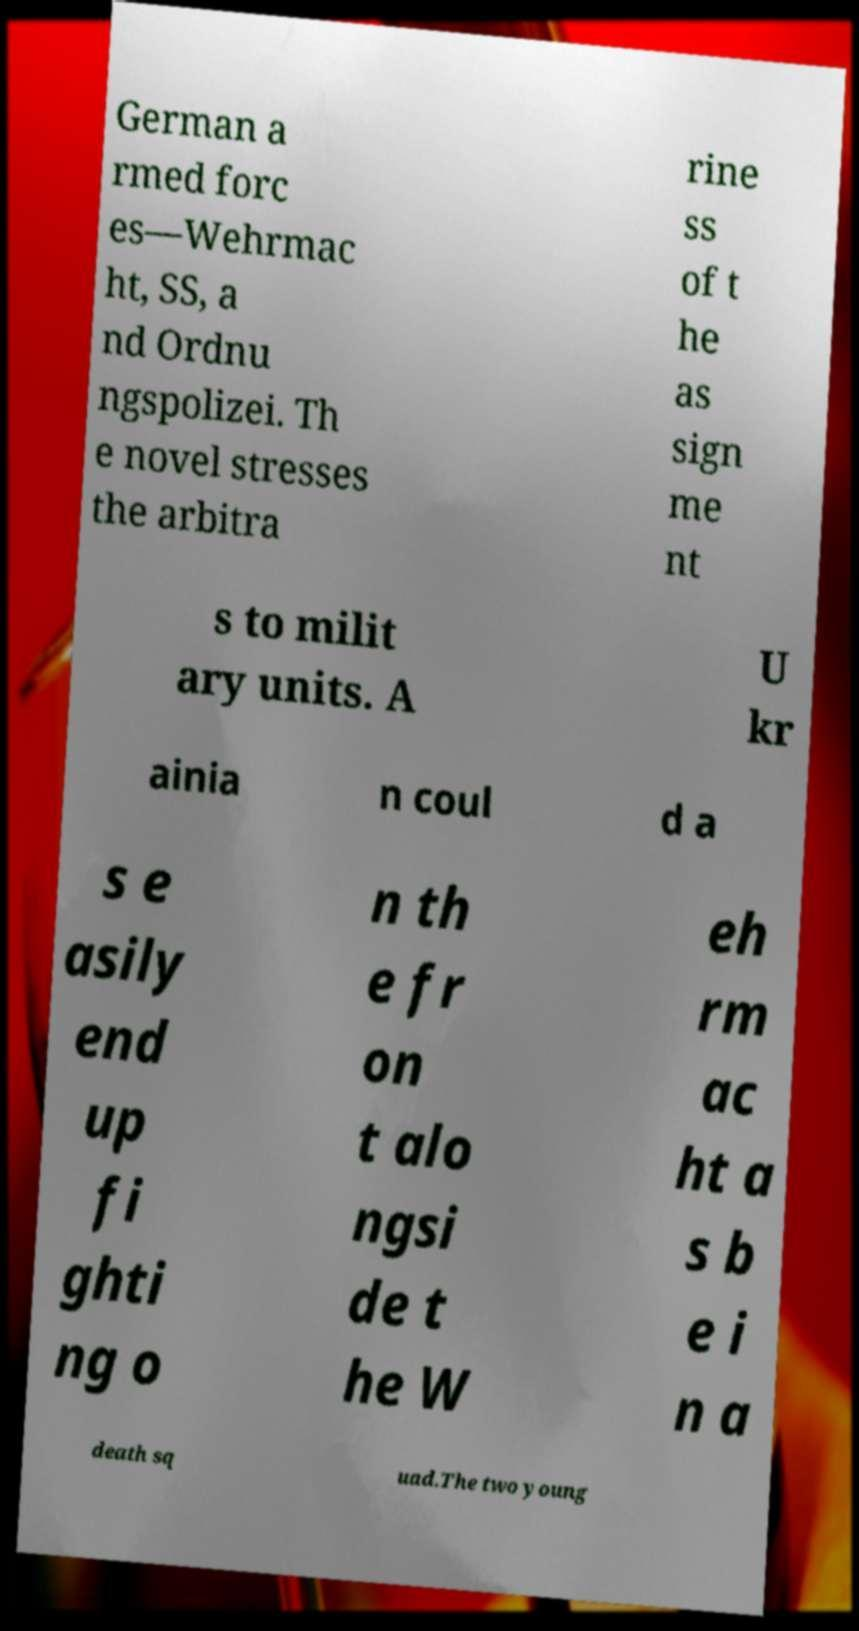I need the written content from this picture converted into text. Can you do that? German a rmed forc es—Wehrmac ht, SS, a nd Ordnu ngspolizei. Th e novel stresses the arbitra rine ss of t he as sign me nt s to milit ary units. A U kr ainia n coul d a s e asily end up fi ghti ng o n th e fr on t alo ngsi de t he W eh rm ac ht a s b e i n a death sq uad.The two young 